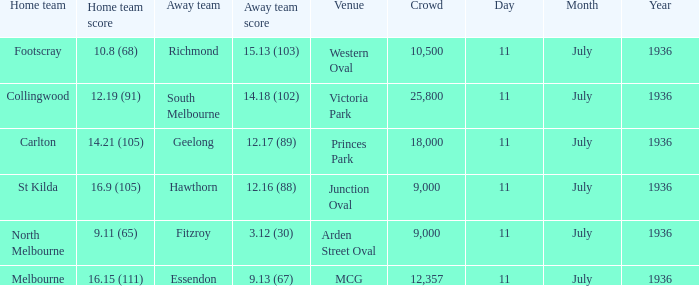What is the lowest crowd seen by the mcg Venue? 12357.0. 